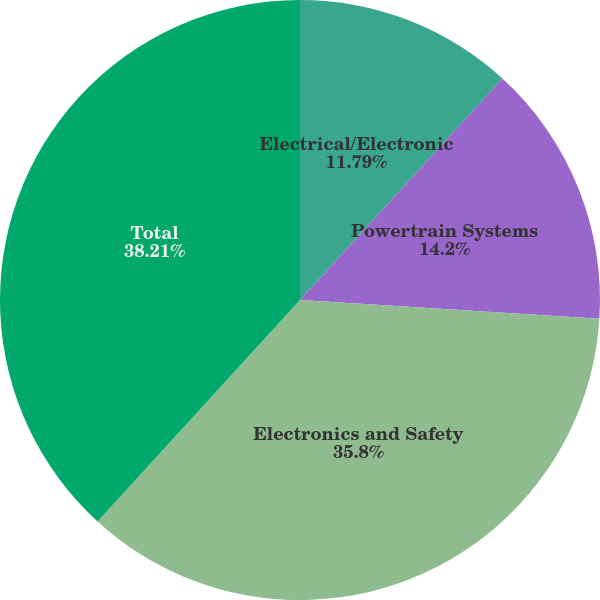<chart> <loc_0><loc_0><loc_500><loc_500><pie_chart><fcel>Electrical/Electronic<fcel>Powertrain Systems<fcel>Electronics and Safety<fcel>Total<nl><fcel>11.79%<fcel>14.2%<fcel>35.8%<fcel>38.21%<nl></chart> 